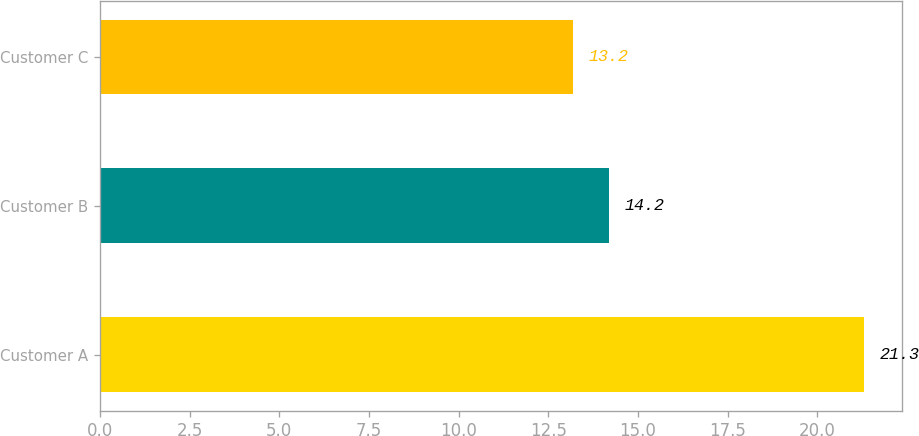Convert chart to OTSL. <chart><loc_0><loc_0><loc_500><loc_500><bar_chart><fcel>Customer A<fcel>Customer B<fcel>Customer C<nl><fcel>21.3<fcel>14.2<fcel>13.2<nl></chart> 